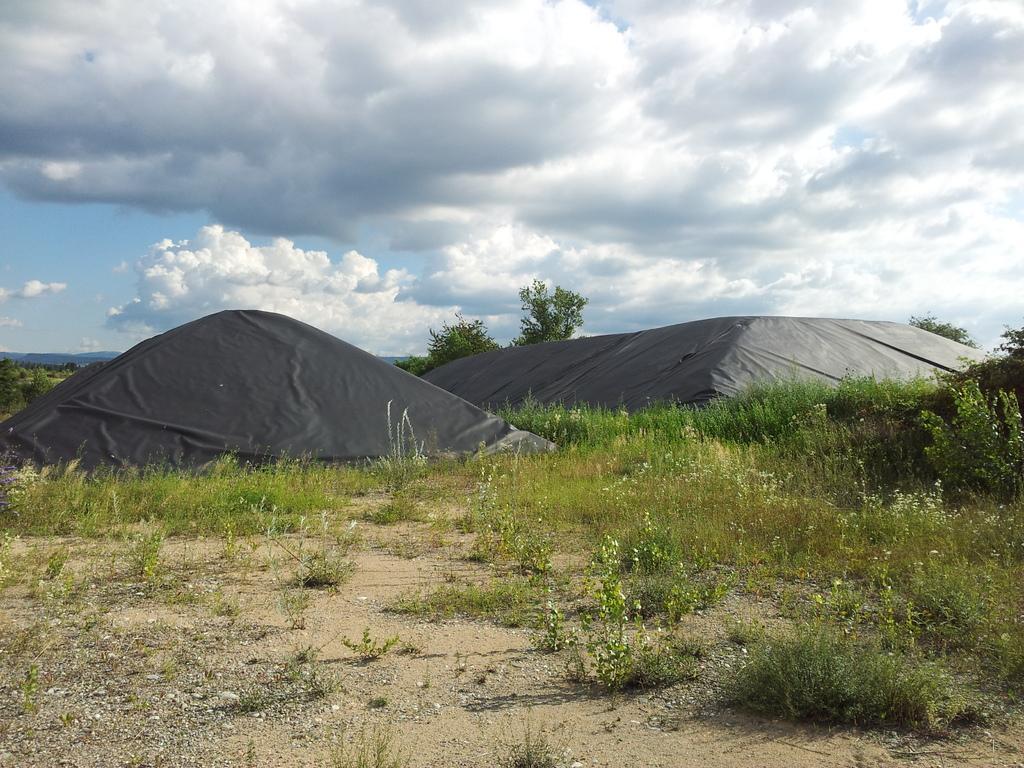How would you summarize this image in a sentence or two? In this image I can see the ground, some grass on the ground which is green in color and few black colored sheets on the ground. In the background I can see few trees and the sky. 